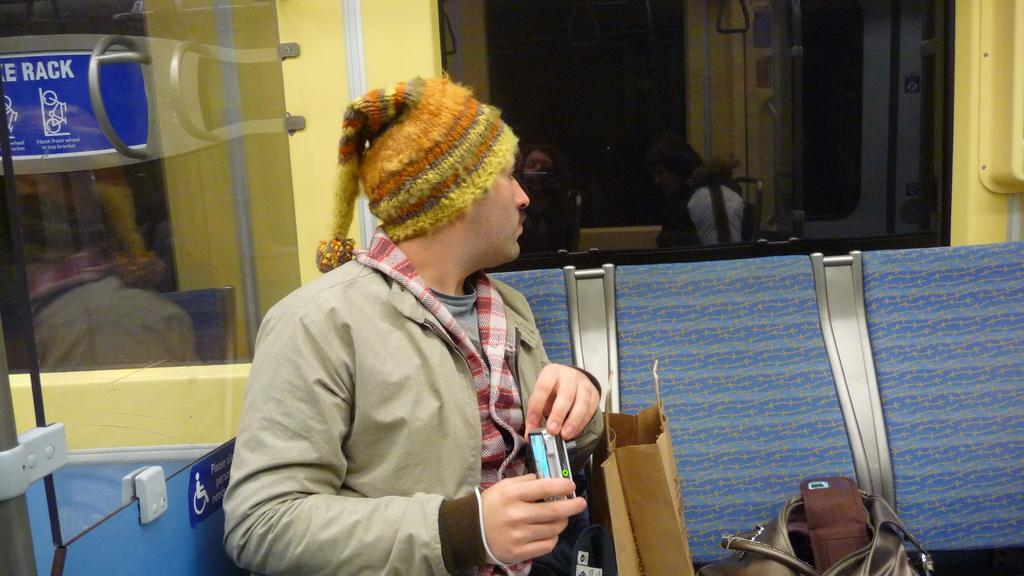What is the man in the image doing? The man is sitting on a bench in the image. What can be seen in the background of the image? There are glass doors in the background of the image. What items are beside the man? There are bags beside the man. What color are the man's eyes in the image? The provided facts do not mention the man's eye color, so it cannot be determined from the image. 